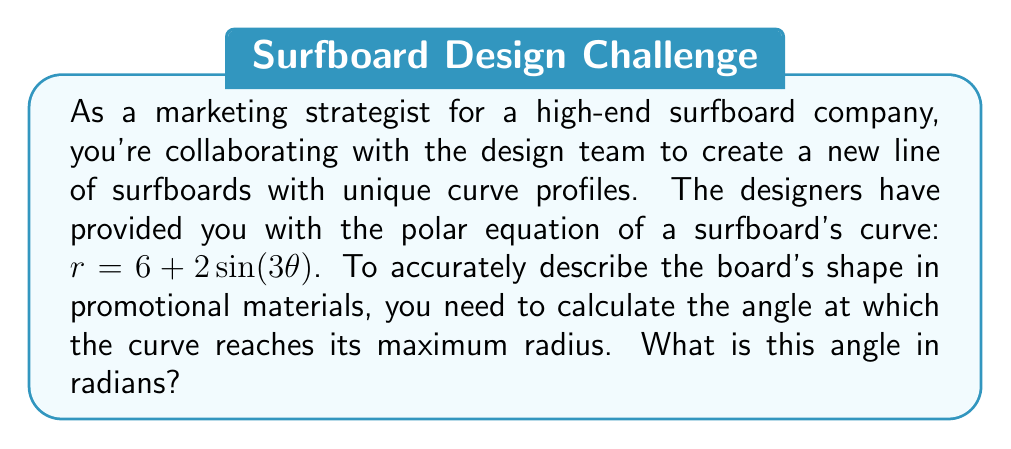Can you answer this question? To find the angle at which the curve reaches its maximum radius, we need to follow these steps:

1) The given equation is $r = 6 + 2\sin(3\theta)$

2) To find the maximum radius, we need to find where $\frac{dr}{d\theta} = 0$

3) Let's differentiate $r$ with respect to $\theta$:

   $$\frac{dr}{d\theta} = 2 \cdot 3 \cos(3\theta) = 6\cos(3\theta)$$

4) Set this equal to zero:

   $$6\cos(3\theta) = 0$$

5) Solve for $\theta$:

   $$\cos(3\theta) = 0$$

   This occurs when $3\theta = \frac{\pi}{2}$ (and other multiples of $\frac{\pi}{2}$, but we're interested in the first occurrence in the positive direction)

6) Solve for $\theta$:

   $$\theta = \frac{\pi}{6}$$

7) To confirm this is a maximum (not a minimum), we can check the second derivative:

   $$\frac{d^2r}{d\theta^2} = -18\sin(3\theta)$$

   At $\theta = \frac{\pi}{6}$, this is negative, confirming a maximum.

Therefore, the curve reaches its maximum radius at $\theta = \frac{\pi}{6}$ radians.
Answer: $\frac{\pi}{6}$ radians 